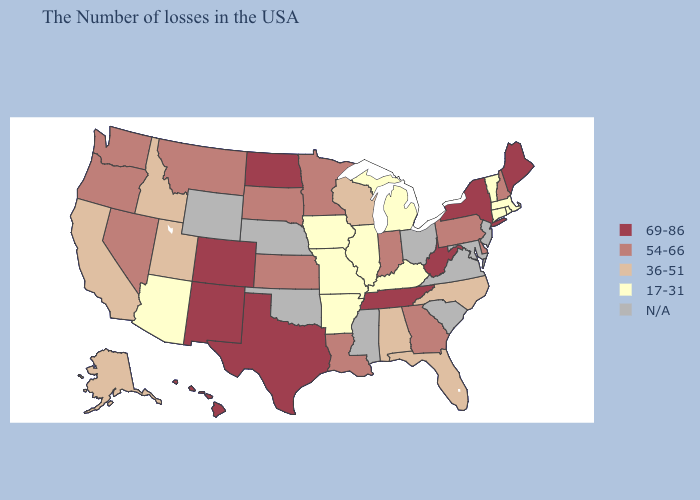Among the states that border New Jersey , does New York have the lowest value?
Answer briefly. No. What is the highest value in states that border Colorado?
Write a very short answer. 69-86. What is the highest value in the USA?
Short answer required. 69-86. Does New Hampshire have the highest value in the Northeast?
Write a very short answer. No. Name the states that have a value in the range N/A?
Give a very brief answer. New Jersey, Maryland, Virginia, South Carolina, Ohio, Mississippi, Nebraska, Oklahoma, Wyoming. What is the lowest value in states that border West Virginia?
Answer briefly. 17-31. Which states have the highest value in the USA?
Write a very short answer. Maine, New York, West Virginia, Tennessee, Texas, North Dakota, Colorado, New Mexico, Hawaii. What is the value of New Mexico?
Give a very brief answer. 69-86. Which states have the lowest value in the USA?
Keep it brief. Massachusetts, Rhode Island, Vermont, Connecticut, Michigan, Kentucky, Illinois, Missouri, Arkansas, Iowa, Arizona. Which states hav the highest value in the South?
Quick response, please. West Virginia, Tennessee, Texas. Among the states that border Michigan , which have the lowest value?
Write a very short answer. Wisconsin. Which states have the highest value in the USA?
Short answer required. Maine, New York, West Virginia, Tennessee, Texas, North Dakota, Colorado, New Mexico, Hawaii. Does the map have missing data?
Short answer required. Yes. Which states have the lowest value in the West?
Give a very brief answer. Arizona. 